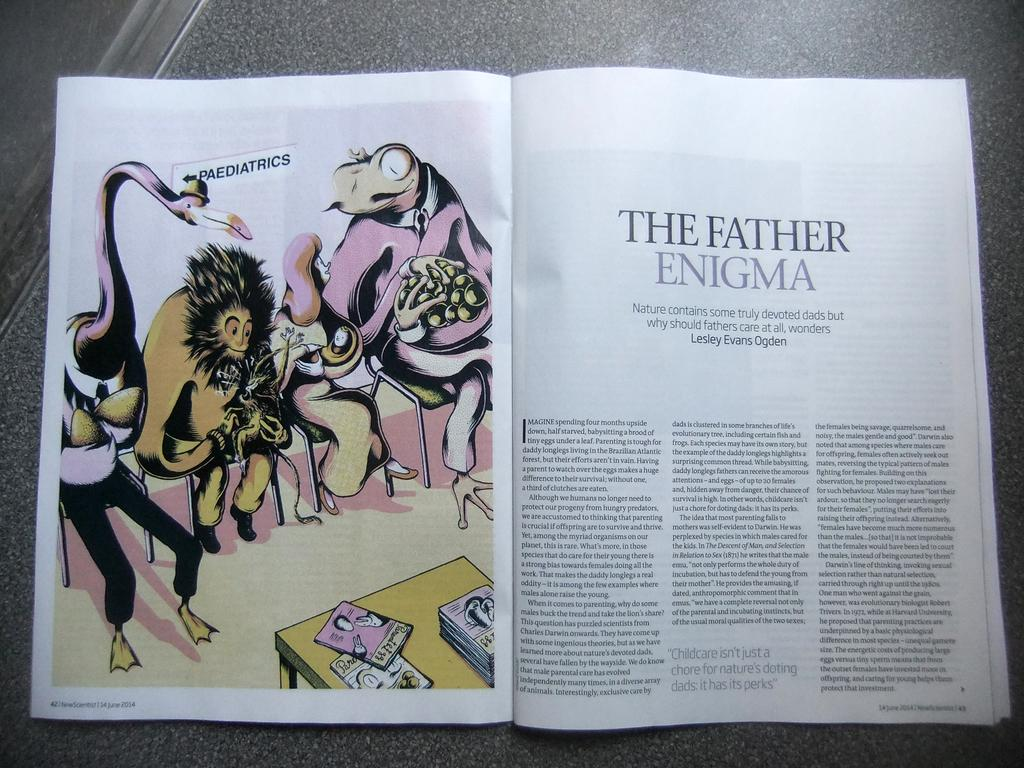<image>
Give a short and clear explanation of the subsequent image. Open book showing weird monsters sitting on a chair titled "The Father Enigma". 